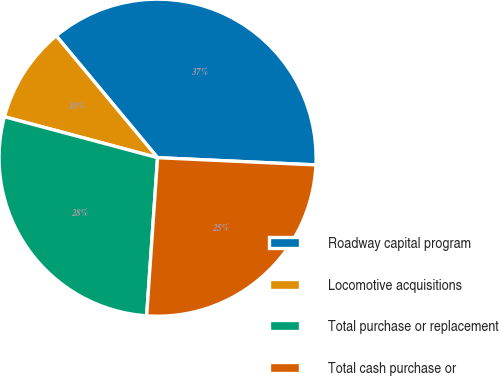Convert chart. <chart><loc_0><loc_0><loc_500><loc_500><pie_chart><fcel>Roadway capital program<fcel>Locomotive acquisitions<fcel>Total purchase or replacement<fcel>Total cash purchase or<nl><fcel>36.77%<fcel>9.8%<fcel>28.06%<fcel>25.37%<nl></chart> 